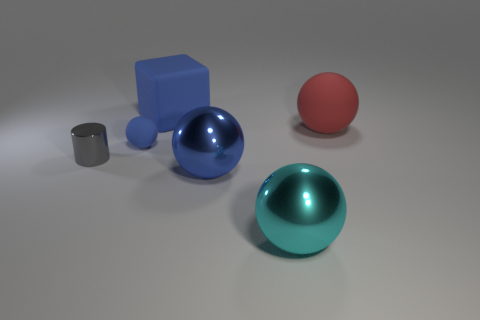Subtract all small rubber balls. How many balls are left? 3 Subtract 1 cylinders. How many cylinders are left? 0 Add 3 rubber objects. How many objects exist? 9 Subtract all balls. How many objects are left? 2 Subtract all green cylinders. Subtract all brown cubes. How many cylinders are left? 1 Subtract all yellow cubes. How many red balls are left? 1 Subtract all small matte spheres. Subtract all big rubber blocks. How many objects are left? 4 Add 6 blue cubes. How many blue cubes are left? 7 Add 3 blue shiny things. How many blue shiny things exist? 4 Subtract all red spheres. How many spheres are left? 3 